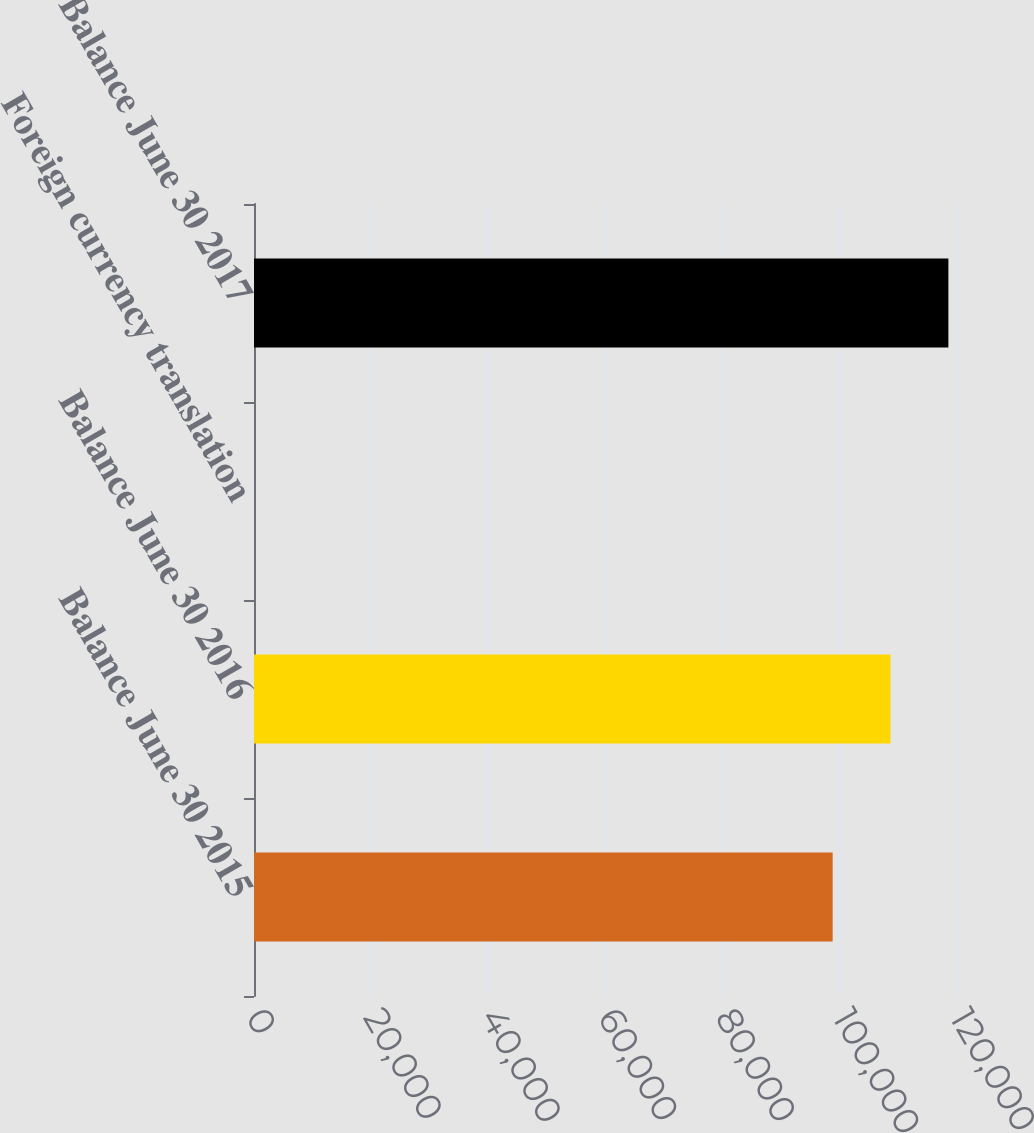Convert chart. <chart><loc_0><loc_0><loc_500><loc_500><bar_chart><fcel>Balance June 30 2015<fcel>Balance June 30 2016<fcel>Foreign currency translation<fcel>Balance June 30 2017<nl><fcel>98634<fcel>108497<fcel>8<fcel>118361<nl></chart> 